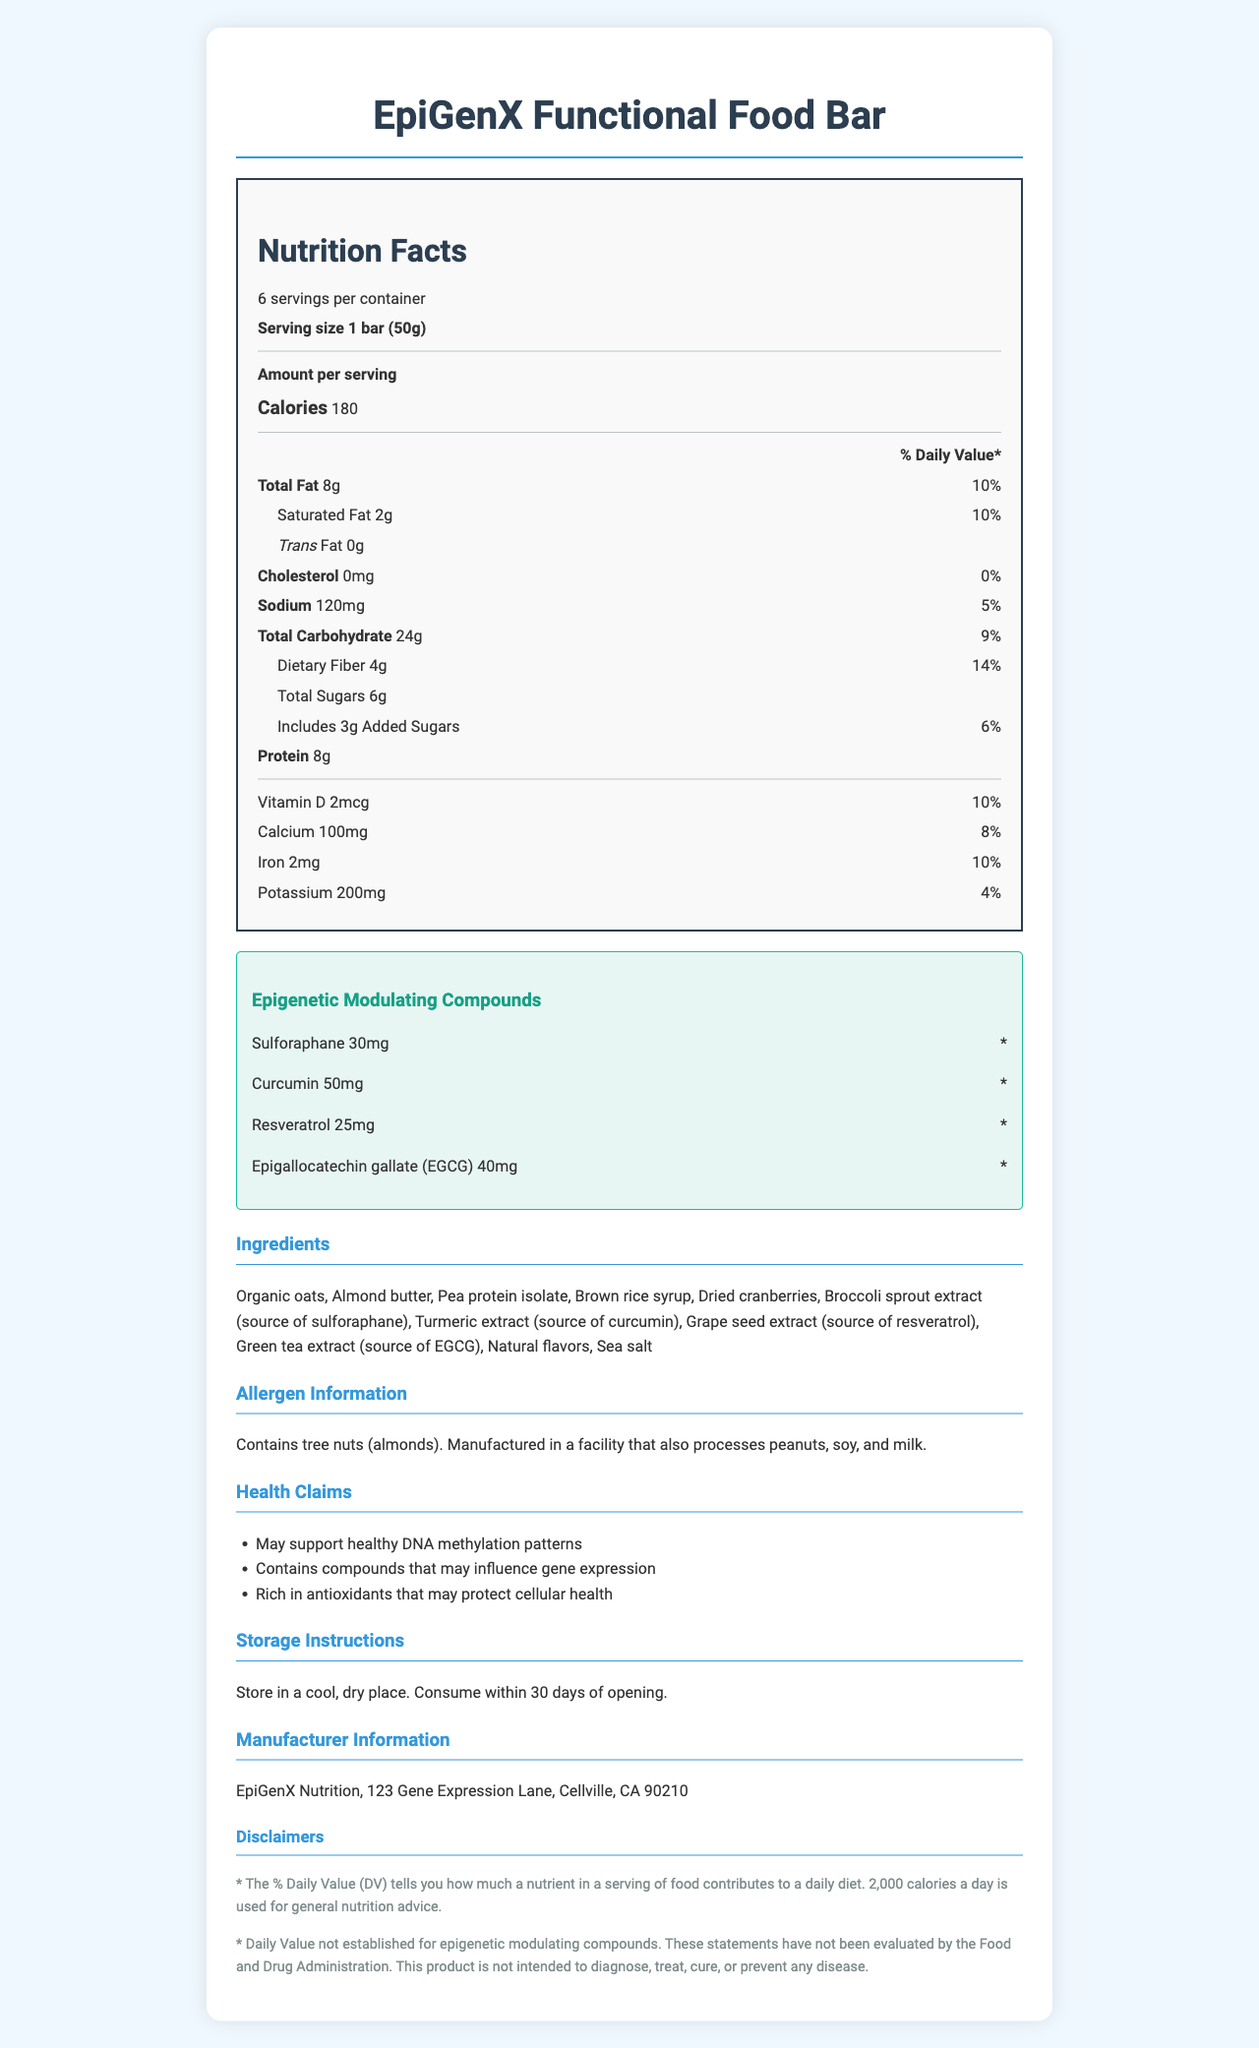what is the serving size for the "EpiGenX Functional Food Bar"? The serving size is clearly listed as "1 bar (50g)" in the document.
Answer: 1 bar (50g) how many calories are in one serving of the "EpiGenX Functional Food Bar"? The document lists the amount of calories per serving as 180.
Answer: 180 what is the total amount of protein per serving? The document lists the protein amount per serving as 8g.
Answer: 8g which ingredient is the source of curcumin in the "EpiGenX Functional Food Bar"? The document mentions that turmeric extract is the source of curcumin.
Answer: Turmeric extract is there any trans fat in the product? The document explicitly states that there is 0g of trans fat.
Answer: No how long can the product be consumed once opened? The storage instructions specify "Consume within 30 days of opening."
Answer: 30 days what percentage of the daily value does the total fat per serving represent? The % Daily Value for total fat is indicated as 10%.
Answer: 10% which of the following is not an epigenetic modulating compound in the "EpiGenX Functional Food Bar"? A. Sulforaphane B. Vitamin C C. Curcumin D. Resveratrol Vitamin C is not listed as one of the epigenetic modulating compounds; the others are included.
Answer: B how much iron is in one serving, and what percentage of the daily value does it represent? The document states that one serving contains 2mg of iron, which is 10% of the daily value.
Answer: 2mg, 10% which claim is made about the antioxidants in the "EpiGenX Functional Food Bar"? A. May support weight loss B. May protect cellular health C. May reduce cholesterol One of the health claims listed is that the product is "Rich in antioxidants that may protect cellular health."
Answer: B does the document specify if the product contains peanuts directly? The document states that it is manufactured in a facility that processes peanuts, but does not specify that peanuts are an ingredient in the bar itself.
Answer: No how many servings are there per container? The document lists that there are 6 servings per container.
Answer: 6 does the product contain dietary fiber, and if so, how much per serving? The document indicates that there is 4g of dietary fiber per serving.
Answer: Yes, 4g summarize the main nutritional and health information of the "EpiGenX Functional Food Bar". This description encompasses the nutrient content, epigenetic compounds, main ingredients, health claims, allergen information, and general storage instructions.
Answer: The "EpiGenX Functional Food Bar" has 180 calories per serving, with 8g of total fat and 8g of protein. It contains epigenetic modulating compounds like Sulforaphane, Curcumin, Resveratrol, and EGCG. Health claims include supporting healthy DNA methylation, influencing gene expression, and protecting cellular health with antioxidants. Key ingredients include organic oats, almond butter, pea protein isolate, and several extracts serving as sources for the epigenetic compounds. The bar contains 4g of dietary fiber per serving and some added sugars. It includes tree nuts and may contain traces of peanuts, soy, and milk. what are the daily values of Sulforaphane and Resveratrol? The document states that the daily values for epigenetic modulating compounds like Sulforaphane and Resveratrol are not established.
Answer: Not established what is the exact address of the manufacturer? The full manufacturer address is listed in the document as "123 Gene Expression Lane, Cellville, CA 90210."
Answer: 123 Gene Expression Lane, Cellville, CA 90210 is the product intended to diagnose, treat, cure, or prevent any disease? The disclaimer clearly states that the product is not intended to diagnose, treat, cure, or prevent any disease.
Answer: No are the amounts of total sugars and added sugars different in the "EpiGenX Functional Food Bar"? The document lists total sugars as 6g and added sugars as 3g, indicating different amounts.
Answer: Yes what is the role of green tea extract in the product? The document specifies that green tea extract is the source of Epigallocatechin gallate (EGCG).
Answer: Source of EGCG 